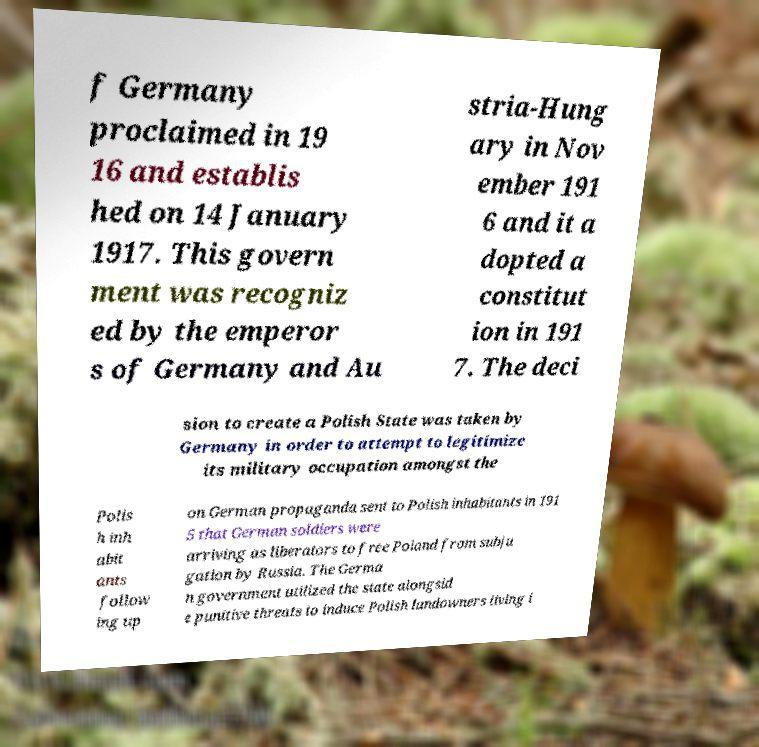What messages or text are displayed in this image? I need them in a readable, typed format. f Germany proclaimed in 19 16 and establis hed on 14 January 1917. This govern ment was recogniz ed by the emperor s of Germany and Au stria-Hung ary in Nov ember 191 6 and it a dopted a constitut ion in 191 7. The deci sion to create a Polish State was taken by Germany in order to attempt to legitimize its military occupation amongst the Polis h inh abit ants follow ing up on German propaganda sent to Polish inhabitants in 191 5 that German soldiers were arriving as liberators to free Poland from subju gation by Russia. The Germa n government utilized the state alongsid e punitive threats to induce Polish landowners living i 